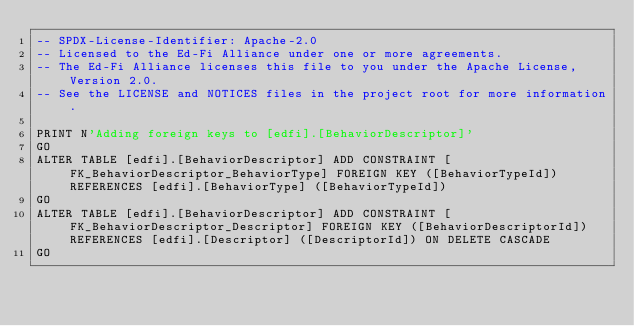Convert code to text. <code><loc_0><loc_0><loc_500><loc_500><_SQL_>-- SPDX-License-Identifier: Apache-2.0
-- Licensed to the Ed-Fi Alliance under one or more agreements.
-- The Ed-Fi Alliance licenses this file to you under the Apache License, Version 2.0.
-- See the LICENSE and NOTICES files in the project root for more information.

PRINT N'Adding foreign keys to [edfi].[BehaviorDescriptor]'
GO
ALTER TABLE [edfi].[BehaviorDescriptor] ADD CONSTRAINT [FK_BehaviorDescriptor_BehaviorType] FOREIGN KEY ([BehaviorTypeId]) REFERENCES [edfi].[BehaviorType] ([BehaviorTypeId])
GO
ALTER TABLE [edfi].[BehaviorDescriptor] ADD CONSTRAINT [FK_BehaviorDescriptor_Descriptor] FOREIGN KEY ([BehaviorDescriptorId]) REFERENCES [edfi].[Descriptor] ([DescriptorId]) ON DELETE CASCADE
GO
</code> 